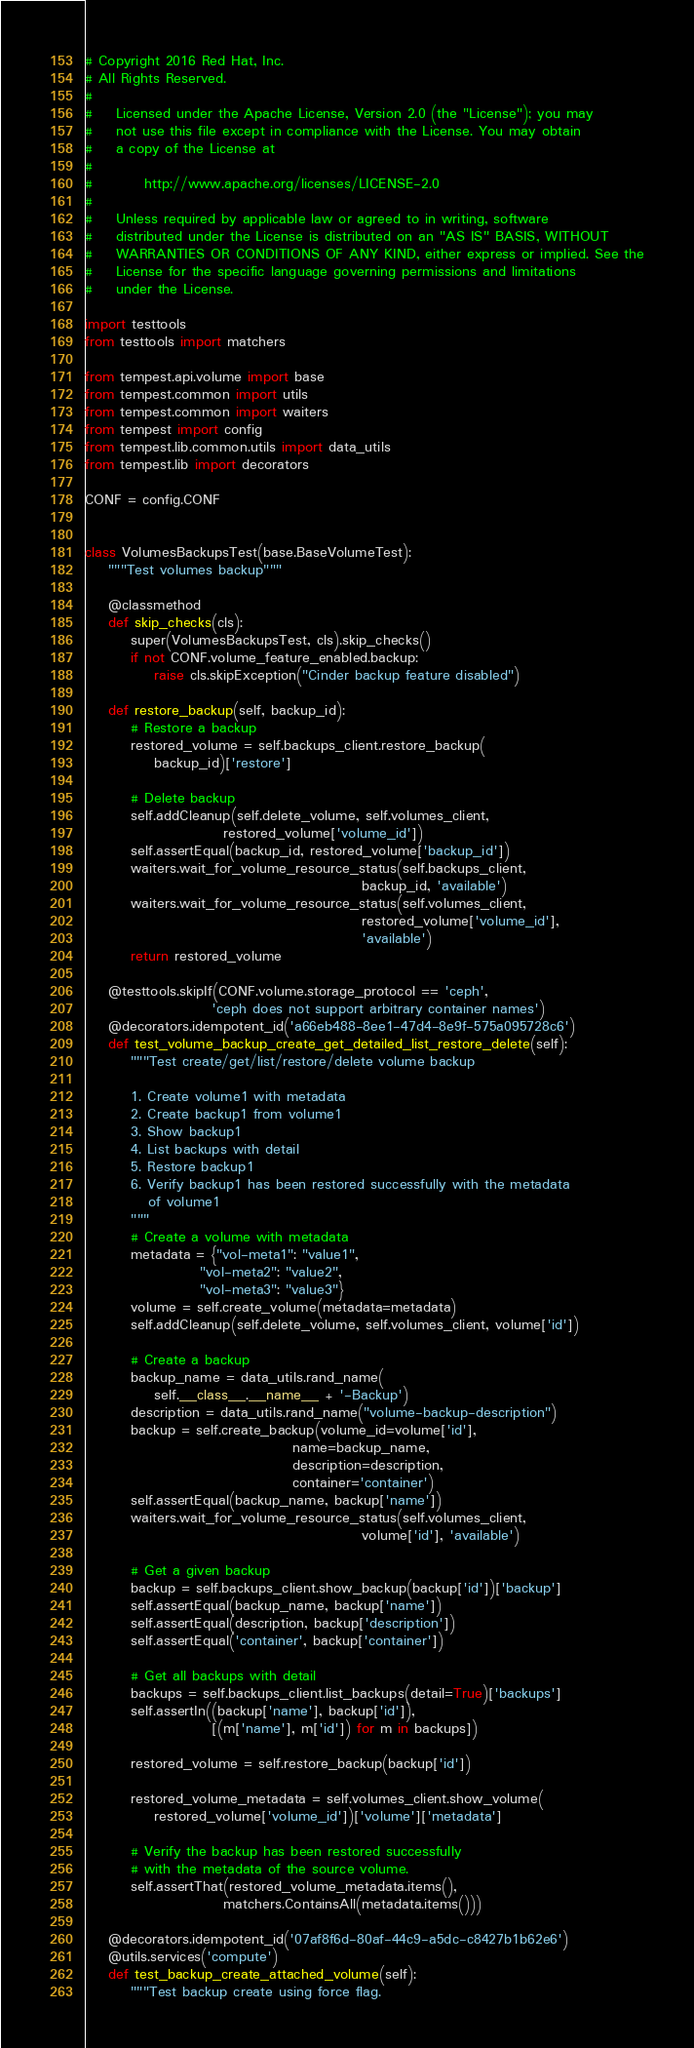<code> <loc_0><loc_0><loc_500><loc_500><_Python_># Copyright 2016 Red Hat, Inc.
# All Rights Reserved.
#
#    Licensed under the Apache License, Version 2.0 (the "License"); you may
#    not use this file except in compliance with the License. You may obtain
#    a copy of the License at
#
#         http://www.apache.org/licenses/LICENSE-2.0
#
#    Unless required by applicable law or agreed to in writing, software
#    distributed under the License is distributed on an "AS IS" BASIS, WITHOUT
#    WARRANTIES OR CONDITIONS OF ANY KIND, either express or implied. See the
#    License for the specific language governing permissions and limitations
#    under the License.

import testtools
from testtools import matchers

from tempest.api.volume import base
from tempest.common import utils
from tempest.common import waiters
from tempest import config
from tempest.lib.common.utils import data_utils
from tempest.lib import decorators

CONF = config.CONF


class VolumesBackupsTest(base.BaseVolumeTest):
    """Test volumes backup"""

    @classmethod
    def skip_checks(cls):
        super(VolumesBackupsTest, cls).skip_checks()
        if not CONF.volume_feature_enabled.backup:
            raise cls.skipException("Cinder backup feature disabled")

    def restore_backup(self, backup_id):
        # Restore a backup
        restored_volume = self.backups_client.restore_backup(
            backup_id)['restore']

        # Delete backup
        self.addCleanup(self.delete_volume, self.volumes_client,
                        restored_volume['volume_id'])
        self.assertEqual(backup_id, restored_volume['backup_id'])
        waiters.wait_for_volume_resource_status(self.backups_client,
                                                backup_id, 'available')
        waiters.wait_for_volume_resource_status(self.volumes_client,
                                                restored_volume['volume_id'],
                                                'available')
        return restored_volume

    @testtools.skipIf(CONF.volume.storage_protocol == 'ceph',
                      'ceph does not support arbitrary container names')
    @decorators.idempotent_id('a66eb488-8ee1-47d4-8e9f-575a095728c6')
    def test_volume_backup_create_get_detailed_list_restore_delete(self):
        """Test create/get/list/restore/delete volume backup

        1. Create volume1 with metadata
        2. Create backup1 from volume1
        3. Show backup1
        4. List backups with detail
        5. Restore backup1
        6. Verify backup1 has been restored successfully with the metadata
           of volume1
        """
        # Create a volume with metadata
        metadata = {"vol-meta1": "value1",
                    "vol-meta2": "value2",
                    "vol-meta3": "value3"}
        volume = self.create_volume(metadata=metadata)
        self.addCleanup(self.delete_volume, self.volumes_client, volume['id'])

        # Create a backup
        backup_name = data_utils.rand_name(
            self.__class__.__name__ + '-Backup')
        description = data_utils.rand_name("volume-backup-description")
        backup = self.create_backup(volume_id=volume['id'],
                                    name=backup_name,
                                    description=description,
                                    container='container')
        self.assertEqual(backup_name, backup['name'])
        waiters.wait_for_volume_resource_status(self.volumes_client,
                                                volume['id'], 'available')

        # Get a given backup
        backup = self.backups_client.show_backup(backup['id'])['backup']
        self.assertEqual(backup_name, backup['name'])
        self.assertEqual(description, backup['description'])
        self.assertEqual('container', backup['container'])

        # Get all backups with detail
        backups = self.backups_client.list_backups(detail=True)['backups']
        self.assertIn((backup['name'], backup['id']),
                      [(m['name'], m['id']) for m in backups])

        restored_volume = self.restore_backup(backup['id'])

        restored_volume_metadata = self.volumes_client.show_volume(
            restored_volume['volume_id'])['volume']['metadata']

        # Verify the backup has been restored successfully
        # with the metadata of the source volume.
        self.assertThat(restored_volume_metadata.items(),
                        matchers.ContainsAll(metadata.items()))

    @decorators.idempotent_id('07af8f6d-80af-44c9-a5dc-c8427b1b62e6')
    @utils.services('compute')
    def test_backup_create_attached_volume(self):
        """Test backup create using force flag.
</code> 